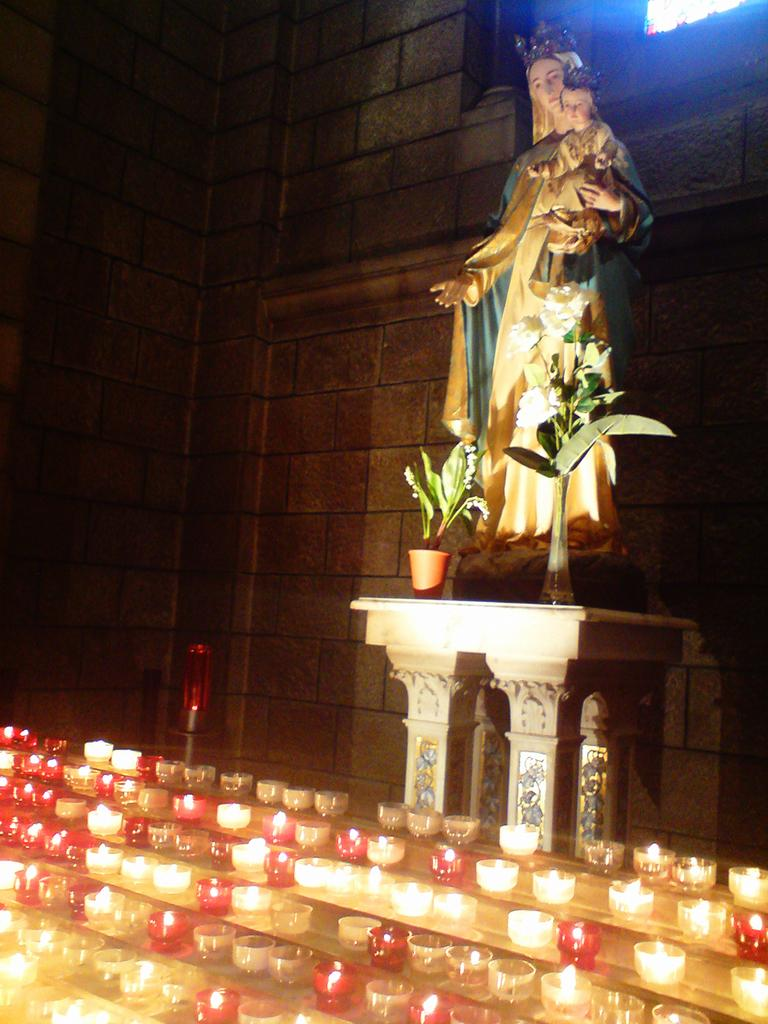What is the main subject of the image? There is a statue of a lady in the image. Where is the statue located in relation to other elements in the image? The statue is in front of a wall. What is in front of the wall? The wall has plants in front of it. What can be seen on the left side of the image? There are many candles in a bowl on steps on the left side of the image. What type of button can be seen on the statue's dress in the image? There is no button visible on the statue's dress in the image. How does the sleet affect the plants in front of the wall? There is no mention of sleet in the image, so its effect on the plants cannot be determined. 